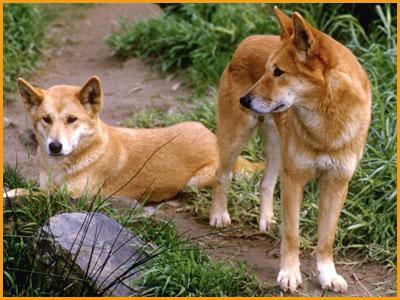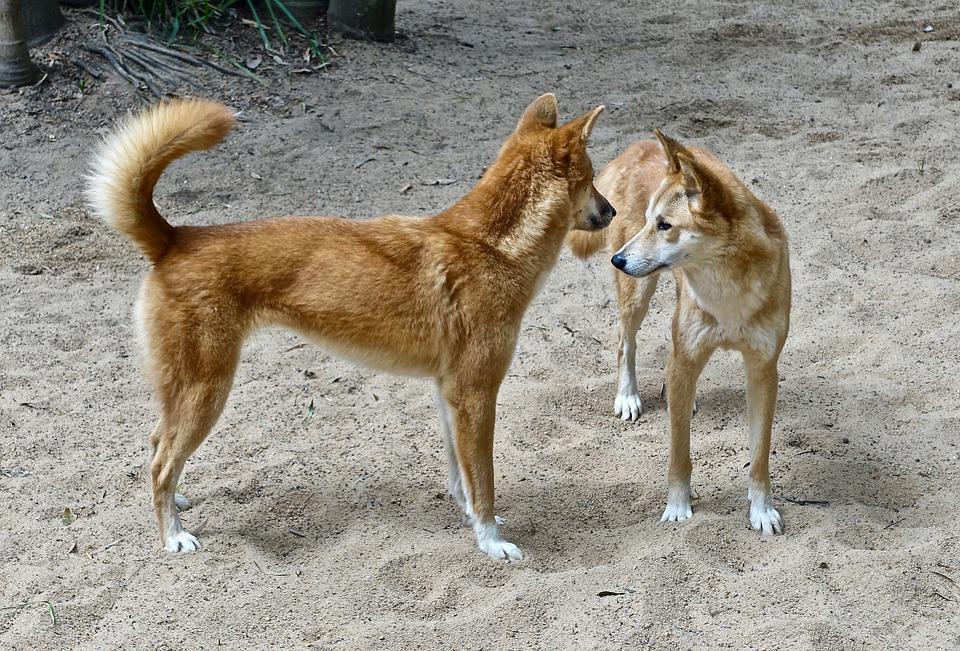The first image is the image on the left, the second image is the image on the right. Given the left and right images, does the statement "The combined images contain a total of four dingos, and at least three of the dogs are standing." hold true? Answer yes or no. Yes. The first image is the image on the left, the second image is the image on the right. Assess this claim about the two images: "There are exactly four animals in the pair of images with at least three of them standing.". Correct or not? Answer yes or no. Yes. 